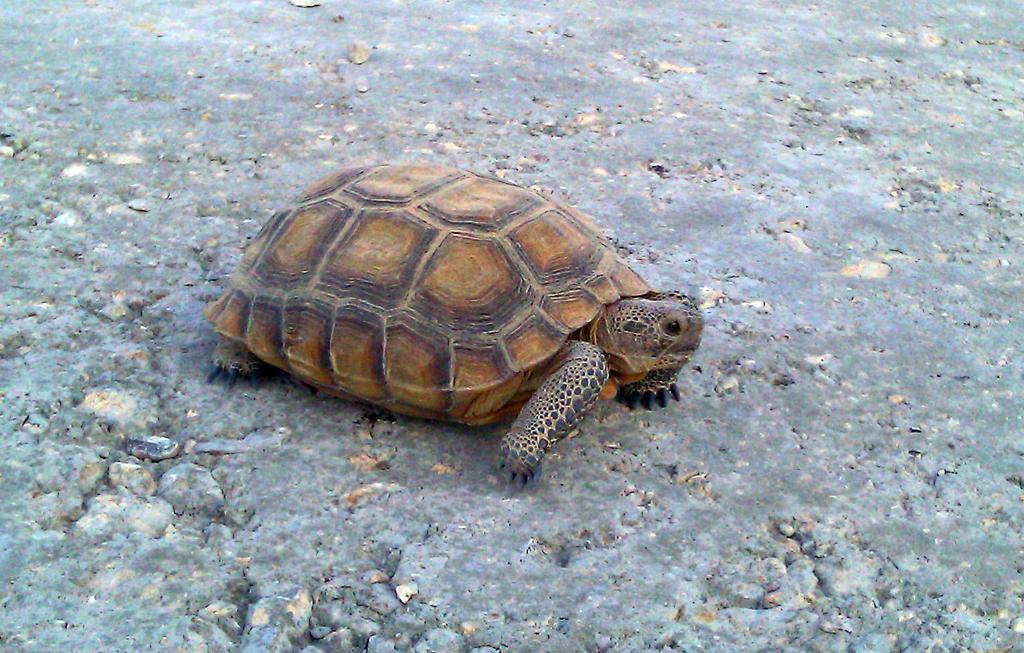What type of animal is in the image? There is a tortoise in the image. Where is the tortoise located in the image? The tortoise is on the ground. What type of door can be seen in the image? There is no door present in the image; it features a tortoise on the ground. What type of juice is the tortoise drinking in the image? There is no juice present in the image, nor is the tortoise shown drinking anything. 